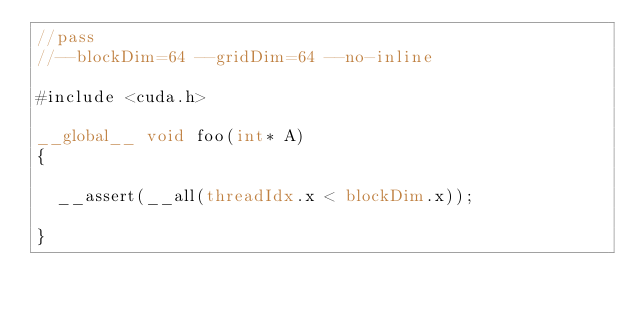<code> <loc_0><loc_0><loc_500><loc_500><_Cuda_>//pass
//--blockDim=64 --gridDim=64 --no-inline

#include <cuda.h>

__global__ void foo(int* A)
{

  __assert(__all(threadIdx.x < blockDim.x));

}
</code> 